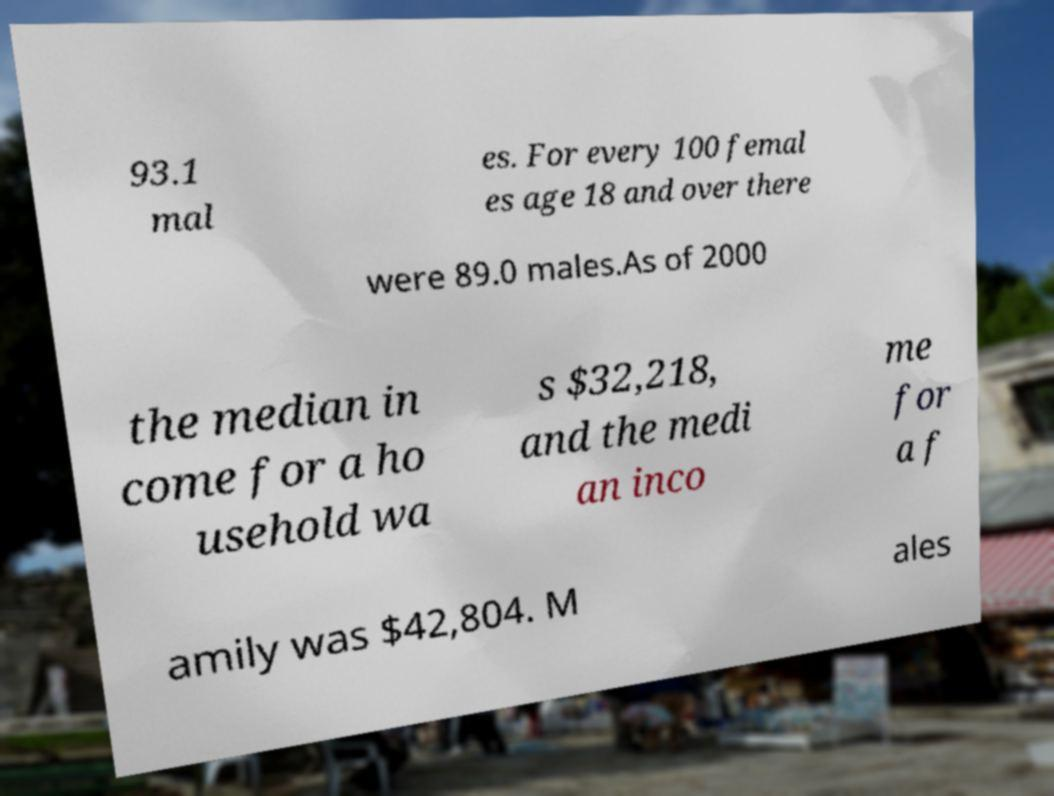Could you extract and type out the text from this image? 93.1 mal es. For every 100 femal es age 18 and over there were 89.0 males.As of 2000 the median in come for a ho usehold wa s $32,218, and the medi an inco me for a f amily was $42,804. M ales 